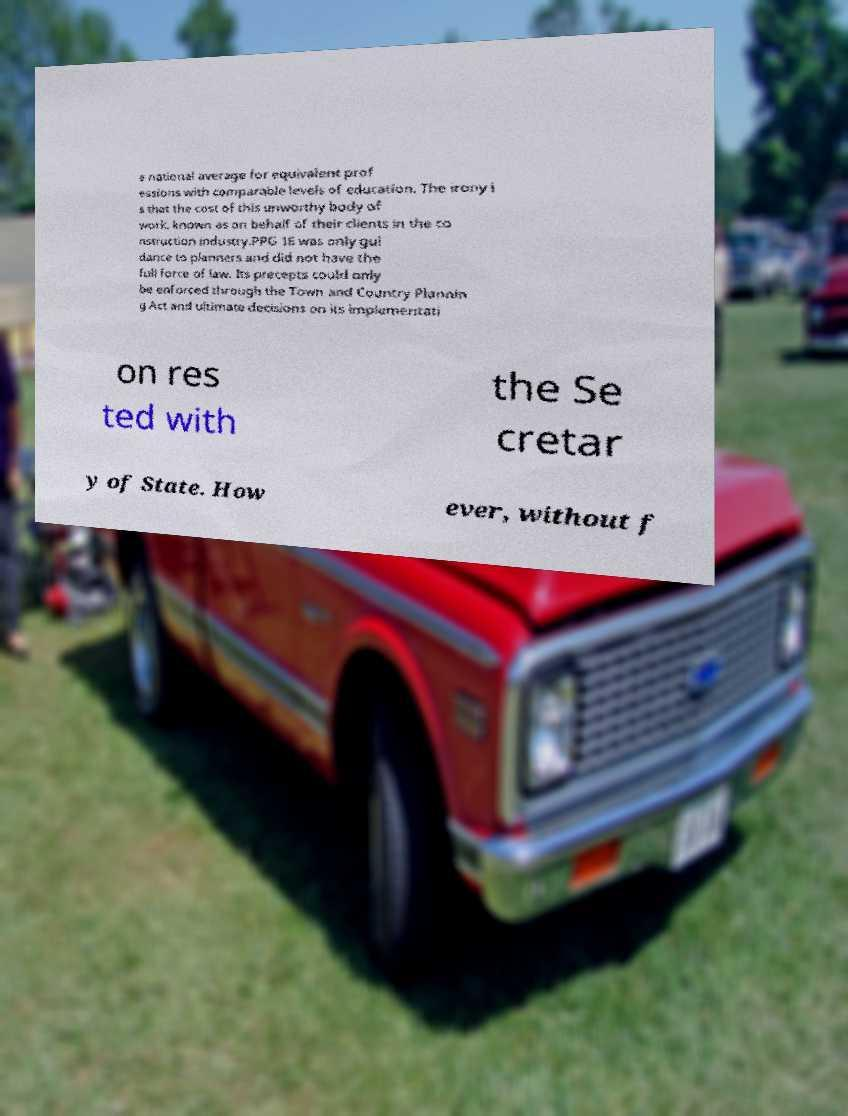For documentation purposes, I need the text within this image transcribed. Could you provide that? e national average for equivalent prof essions with comparable levels of education. The irony i s that the cost of this unworthy body of work, known as on behalf of their clients in the co nstruction industry.PPG 16 was only gui dance to planners and did not have the full force of law. Its precepts could only be enforced through the Town and Country Plannin g Act and ultimate decisions on its implementati on res ted with the Se cretar y of State. How ever, without f 